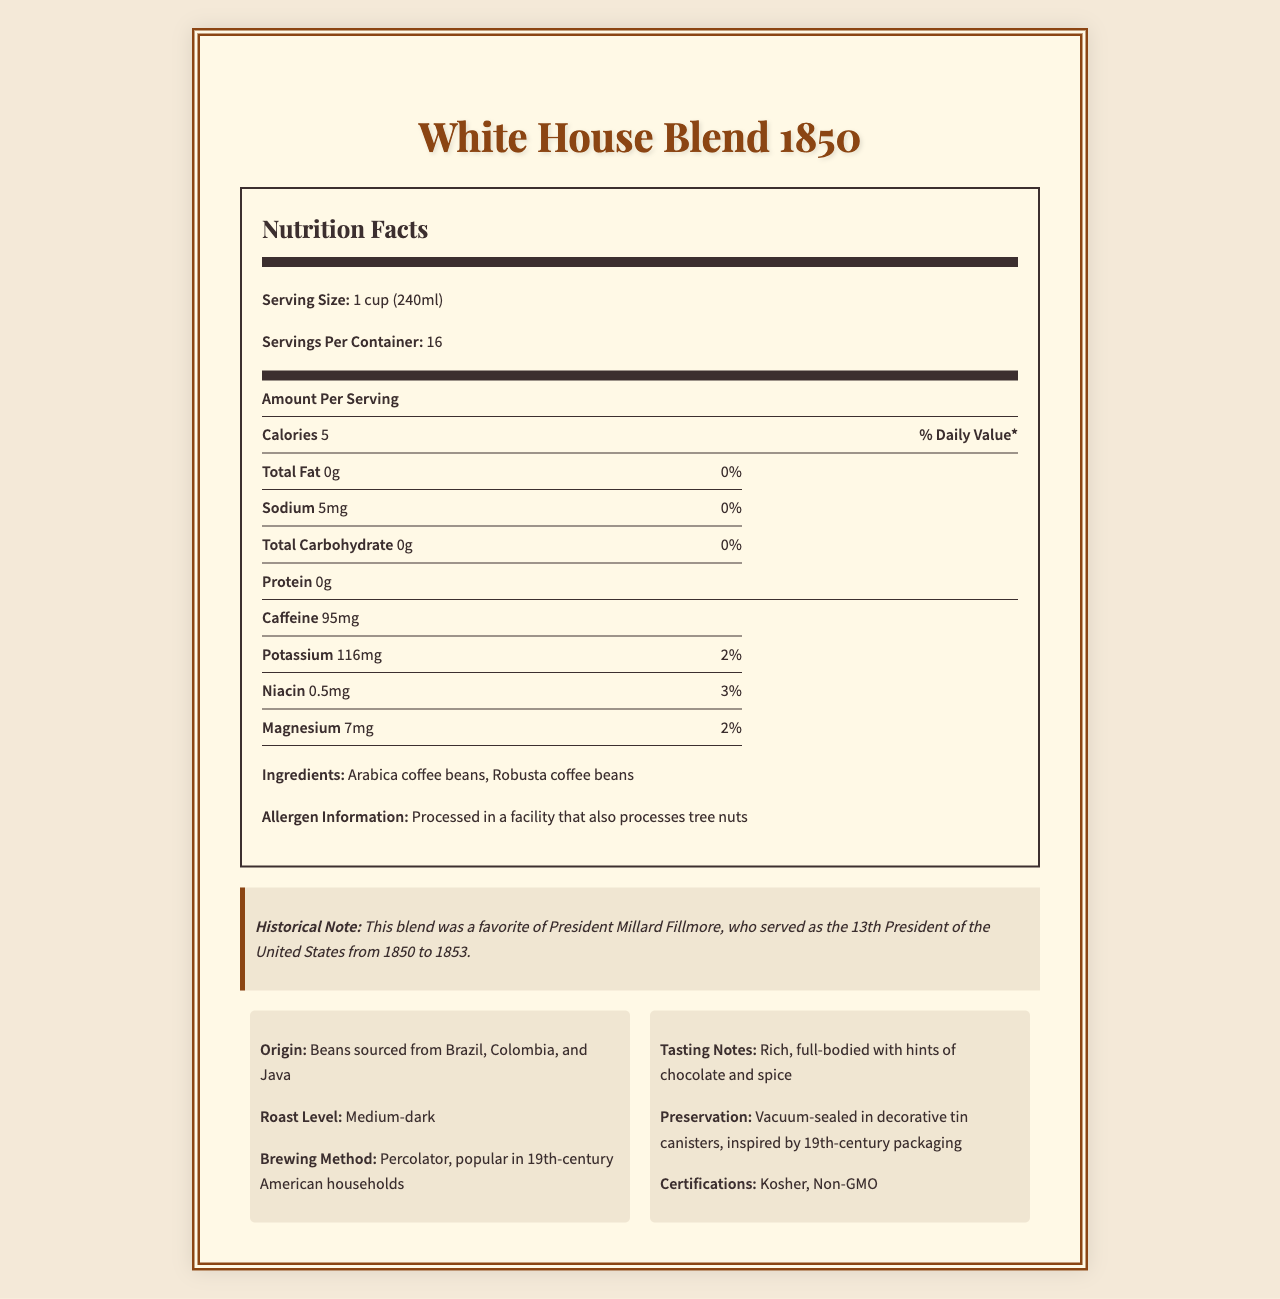how many servings are in one container? The document specifies "Servings Per Container: 16," indicating the total number of servings in one container.
Answer: 16 what is the serving size of the White House Blend 1850? The document states that the serving size is "1 cup (240ml)."
Answer: 1 cup (240ml) how many calories are there per serving? The document lists "Calories: 5" for the amount per serving.
Answer: 5 what is the caffeine content per serving? The document specifies "Caffeine: 95mg" per serving.
Answer: 95mg name two minerals found in the coffee blend. The document lists "Potassium: 116mg" and "Magnesium: 7mg" under nutrition facts.
Answer: Potassium, Magnesium which President favored this coffee blend? A. John Adams B. Millard Fillmore C. Abraham Lincoln D. Andrew Jackson The historical note states that this blend was a favorite of President Millard Fillmore.
Answer: B how much sodium is in one serving? The document lists "Sodium: 5mg" per serving.
Answer: 5mg what is the roast level of the coffee? A. Light B. Medium C. Medium-dark D. Dark The document states that the roast level is "Medium-dark."
Answer: C does the coffee contain any allergens? The allergen information specifies that it is "Processed in a facility that also processes tree nuts."
Answer: Yes what are the main ingredients of the White House Blend 1850? The document lists the ingredients as "Arabica coffee beans, Robusta coffee beans."
Answer: Arabica coffee beans, Robusta coffee beans where are the coffee beans sourced from? The document specifies that the beans are sourced from "Brazil, Colombia, and Java."
Answer: Brazil, Colombia, and Java what are the tasting notes of the coffee? The document describes the tasting notes as "Rich, full-bodied with hints of chocolate and spice."
Answer: Rich, full-bodied with hints of chocolate and spice what preservation method is used for the coffee? The document indicates that the coffee is "Vacuum-sealed in decorative tin canisters, inspired by 19th-century packaging."
Answer: Vacuum-sealed in decorative tin canisters, inspired by 19th-century packaging does the coffee contain any protein? The document lists "Protein: 0g," indicating there is no protein.
Answer: No how is this coffee historically significant? The document's historical note states that this blend was a favorite of President Millard Fillmore.
Answer: Favorite of President Millard Fillmore is this product GMO-free? The dietary certifications include "Non-GMO."
Answer: Yes describe the main idea of the document. The document details the nutritional content per serving, ingredients, allergen information, historical note, origin, roast level, brewing method, tasting notes, preservation method, and dietary certifications of the White House Blend 1850 coffee.
Answer: The document provides nutritional information, historical significance, and other attributes of the White House Blend 1850 coffee, a medium-dark roast popular in the 19th century and enjoyed by President Millard Fillmore. where is the product sold? The document provides detailed information about the coffee's nutritional facts and historical significance but does not include information about where the product is sold.
Answer: Cannot be determined 